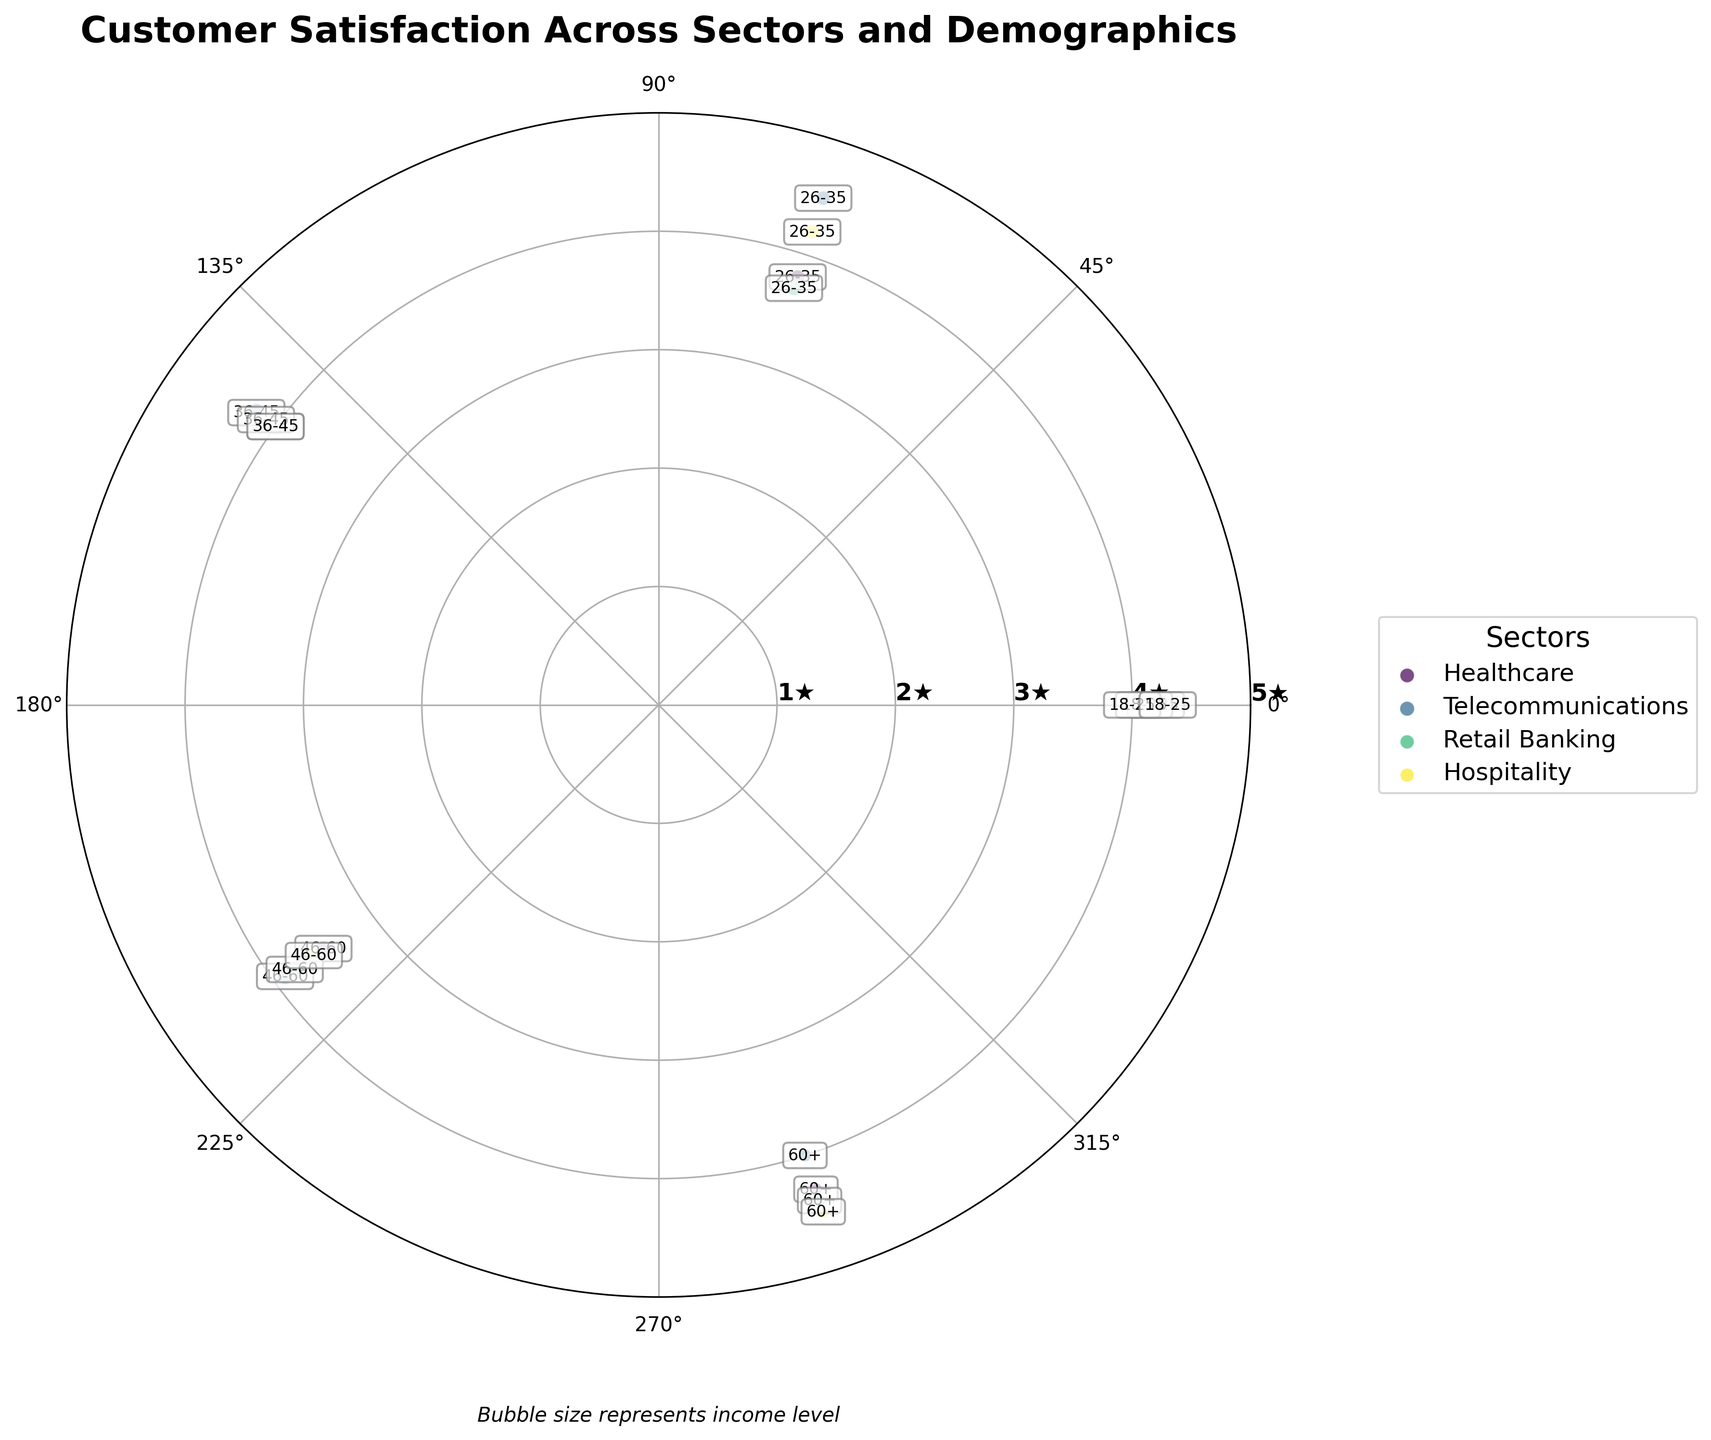What is the title of the figure? The title is usually displayed at the top of the chart. It provides a summary of what the chart represents. In this case, the title at the top of the chart is "Customer Satisfaction Across Sectors and Demographics".
Answer: Customer Satisfaction Across Sectors and Demographics What do the bubble sizes represent? This type of detail is typically inscribed somewhere around the legend or near the chart, and here the annotation mentions that the bubble size represents income level.
Answer: Income level Which sector has the highest satisfaction rating among the 18-25 demographic? By looking at the sector labels and the associated satisfaction ratings for the 18-25 demographic, it is clear that the Hospitality sector has the highest rating of 4.3.
Answer: Hospitality What is the average satisfaction rating for the 26-35 demographic group across all sectors? Locate all ratings for the 26-35 demographic group (Healthcare: 3.8, Telecommunications: 4.5, Retail Banking: 3.7, Hospitality: 4.2). Sum them up and divide by the number of sectors (3.8 + 4.5 + 3.7 + 4.2)/4 = 16.2/4 = 4.05.
Answer: 4.05 Which service sector shows the largest variation in satisfaction ratings across different demographic groups? To determine this, compare the range of ratings (difference between highest and lowest rating) for each sector: 
- Healthcare: 4.3 - 3.5 = 0.8
- Telecommunications: 4.5 - 3.9 = 0.6
- Retail Banking: 4.4 - 3.7 = 0.7
- Hospitality: 4.5 - 3.6 = 0.9 
Thus, Hospitality shows the largest variation of 0.9.
Answer: Hospitality Which demographic group shows the highest satisfaction rating across all sectors? Compare the highest ratings across all sectors for each demographic group. The highest ratings are:
- 18-25: 4.3 in Hospitality
- 26-35: 4.5 in Telecommunications
- 36-45: 4.2 in Retail Banking
- 46-60: 3.9 in Telecommunications
- 60+: 4.5 in Hospitality
Thus, the highest rating is 4.5, found in both the 26-35 and 60+ groups.
Answer: 26-35 and 60+ What is the range of satisfaction ratings in the Retail Banking sector? Identify the highest and lowest rating values in the Retail Banking sector (highest is 4.4, lowest is 3.7) then compute the range: 4.4 - 3.7 = 0.7.
Answer: 0.7 Does the Telecommunications sector have more non-senior populations (below 60) represented than the Healthcare sector? Count the points below the 60+ demographic group for each sector: 
- Telecommunications: 4 points (18-25, 26-35, 36-45, 46-60)
- Healthcare: 4 points (18-25, 26-35, 36-45, 46-60)
Both sectors have an equal number of 4 non-senior population data points.
Answer: No Which sector has the lowest satisfaction rating for the 60+ demographic group? Locate and compare the satisfaction ratings for the 60+ demographic across sectors. The lowest rating is in Telecommunications with a rating of 4.0.
Answer: Telecommunications 